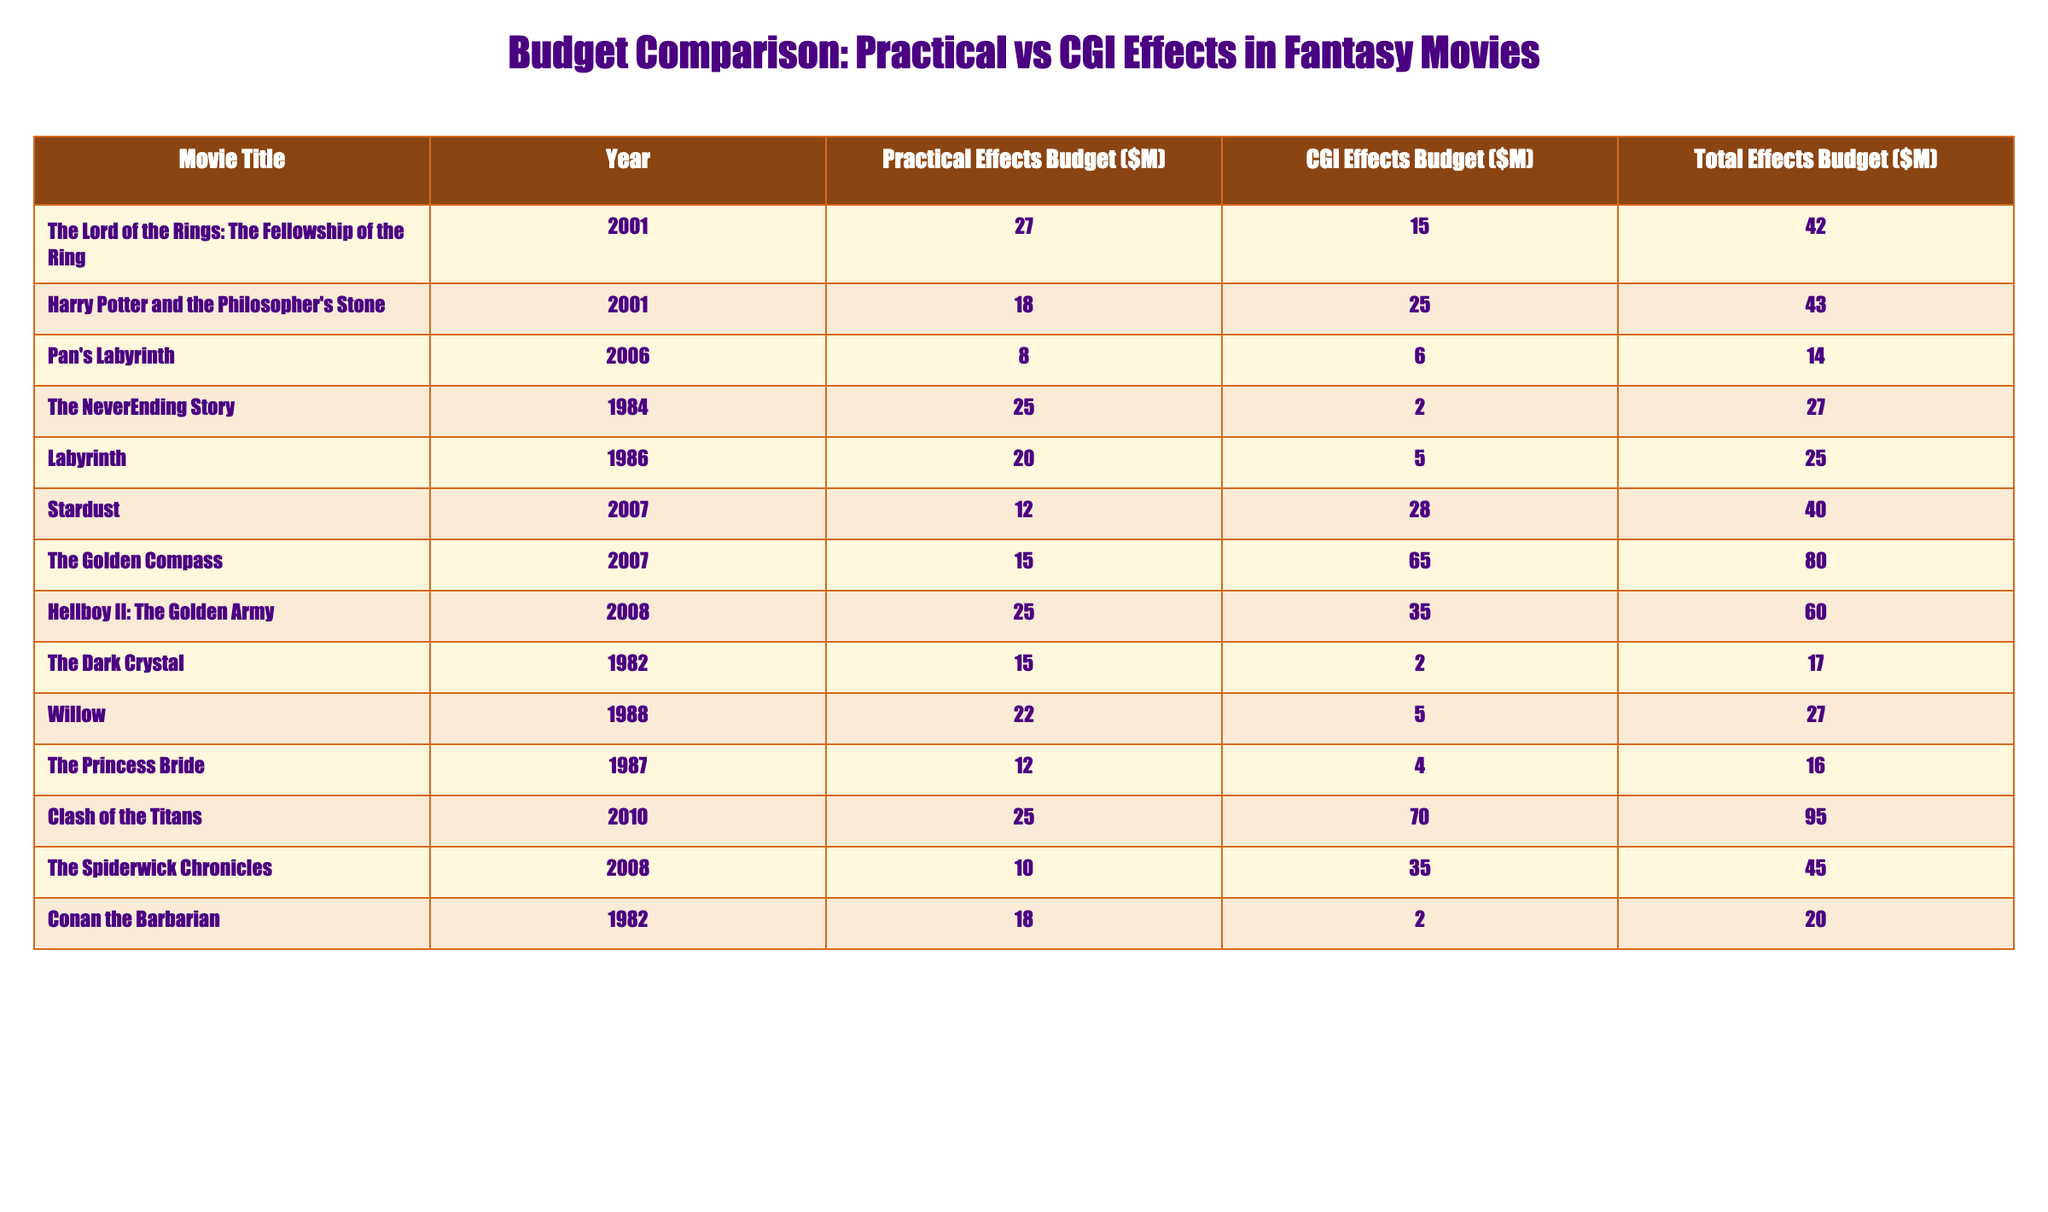What is the total effects budget for "The Lord of the Rings: The Fellowship of the Ring"? By looking at the row for "The Lord of the Rings: The Fellowship of the Ring," we see that the total effects budget is listed as $42 million.
Answer: 42 million Which movie had the highest budget for practical effects? By inspecting the practical effects budget column, we find that "Clash of the Titans" has the highest practical effects budget of $25 million.
Answer: Clash of the Titans What is the difference between the CGI effects budget of "Harry Potter and the Philosopher's Stone" and "Pan's Labyrinth"? The CGI effects budget for "Harry Potter and the Philosopher's Stone" is $25 million, and for "Pan's Labyrinth," it is $6 million. The difference is $25M - $6M = $19 million.
Answer: 19 million Is the CGI effects budget for "The Golden Compass" greater than its practical effects budget? For "The Golden Compass," the practical effects budget is $15 million, and the CGI effects budget is $65 million, which is greater.
Answer: Yes What is the average total effects budget for the movies listed in the table? To find the average, we sum all the total effects budgets: 42 + 43 + 14 + 27 + 25 + 40 + 80 + 60 + 17 + 27 + 16 + 95 + 45 + 20 =  476 million. There are 14 movies, so the average is 476 million / 14 ≈ 34 million.
Answer: Approximately 34 million Which movie had the smallest practical effects budget? The smallest practical effects budget is found by inspecting the practical effects budget column. "Pan's Labyrinth" has the smallest budget at $8 million.
Answer: Pan's Labyrinth How much more was spent on CGI effects in "Clash of the Titans" compared to "The Dark Crystal"? The CGI budget for "Clash of the Titans" is $70 million, while for "The Dark Crystal," it is $2 million. The difference is $70M - $2M = $68 million.
Answer: 68 million What percentage of the total effects budget did practical effects account for in "Hellboy II: The Golden Army"? The total effects budget for "Hellboy II: The Golden Army" is $60 million, and the practical effects budget is $25 million. To find the percentage, we calculate (25M / 60M) * 100 = 41.67%.
Answer: Approximately 41.67% Can we identify any trend regarding the relationship between practical effects and CGI effects budgets in the table? By analyzing the data, we can observe that in some cases, movies spend more on CGI effects than practical effects, especially in newer films, which indicates a trend towards increased CGI reliance.
Answer: Yes, trend toward increased CGI reliance 